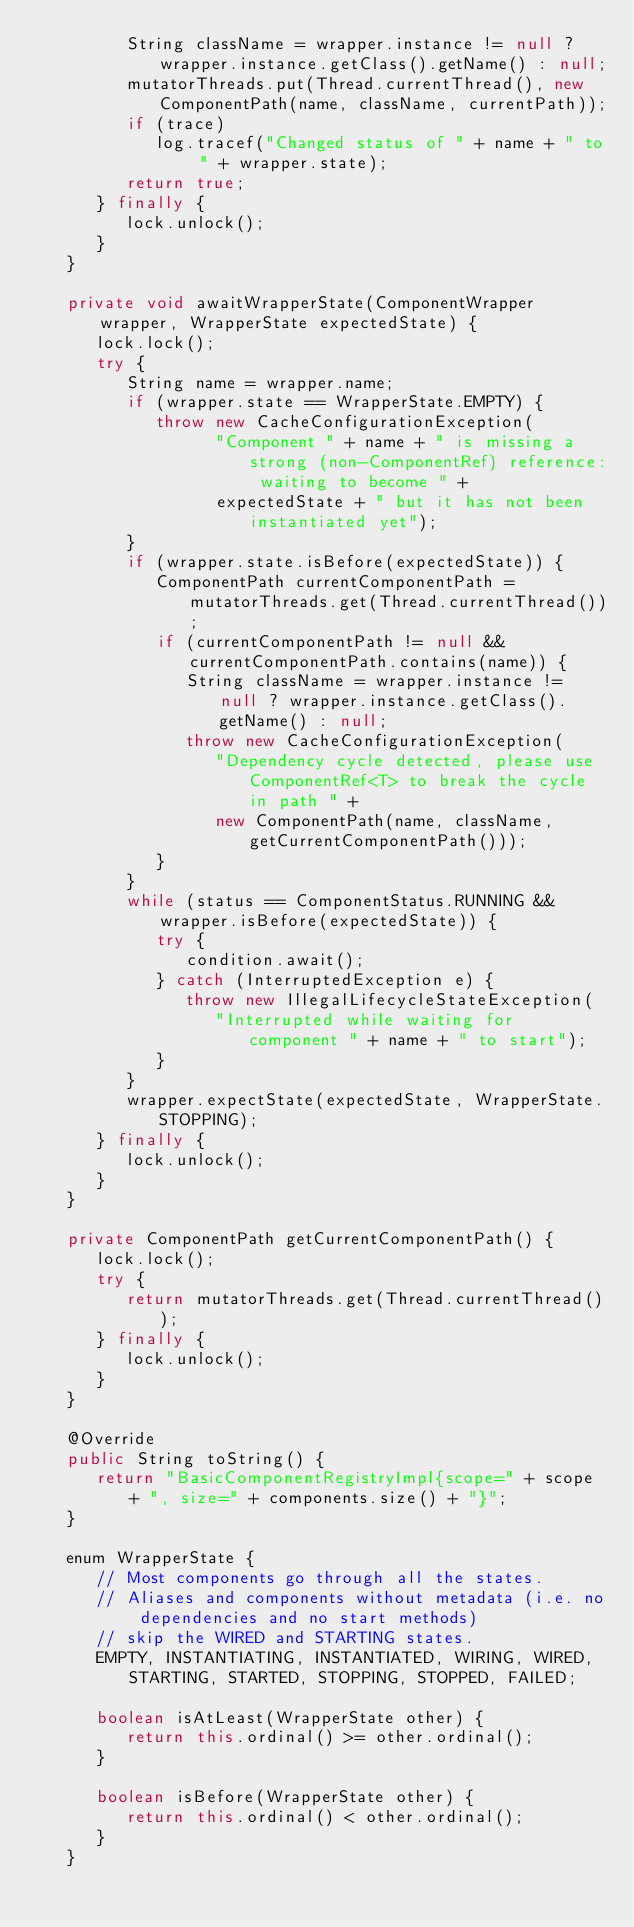<code> <loc_0><loc_0><loc_500><loc_500><_Java_>         String className = wrapper.instance != null ? wrapper.instance.getClass().getName() : null;
         mutatorThreads.put(Thread.currentThread(), new ComponentPath(name, className, currentPath));
         if (trace)
            log.tracef("Changed status of " + name + " to " + wrapper.state);
         return true;
      } finally {
         lock.unlock();
      }
   }

   private void awaitWrapperState(ComponentWrapper wrapper, WrapperState expectedState) {
      lock.lock();
      try {
         String name = wrapper.name;
         if (wrapper.state == WrapperState.EMPTY) {
            throw new CacheConfigurationException(
                  "Component " + name + " is missing a strong (non-ComponentRef) reference: waiting to become " +
                  expectedState + " but it has not been instantiated yet");
         }
         if (wrapper.state.isBefore(expectedState)) {
            ComponentPath currentComponentPath = mutatorThreads.get(Thread.currentThread());
            if (currentComponentPath != null && currentComponentPath.contains(name)) {
               String className = wrapper.instance != null ? wrapper.instance.getClass().getName() : null;
               throw new CacheConfigurationException(
                  "Dependency cycle detected, please use ComponentRef<T> to break the cycle in path " +
                  new ComponentPath(name, className, getCurrentComponentPath()));
            }
         }
         while (status == ComponentStatus.RUNNING && wrapper.isBefore(expectedState)) {
            try {
               condition.await();
            } catch (InterruptedException e) {
               throw new IllegalLifecycleStateException(
                  "Interrupted while waiting for component " + name + " to start");
            }
         }
         wrapper.expectState(expectedState, WrapperState.STOPPING);
      } finally {
         lock.unlock();
      }
   }

   private ComponentPath getCurrentComponentPath() {
      lock.lock();
      try {
         return mutatorThreads.get(Thread.currentThread());
      } finally {
         lock.unlock();
      }
   }

   @Override
   public String toString() {
      return "BasicComponentRegistryImpl{scope=" + scope + ", size=" + components.size() + "}";
   }

   enum WrapperState {
      // Most components go through all the states.
      // Aliases and components without metadata (i.e. no dependencies and no start methods)
      // skip the WIRED and STARTING states.
      EMPTY, INSTANTIATING, INSTANTIATED, WIRING, WIRED, STARTING, STARTED, STOPPING, STOPPED, FAILED;

      boolean isAtLeast(WrapperState other) {
         return this.ordinal() >= other.ordinal();
      }

      boolean isBefore(WrapperState other) {
         return this.ordinal() < other.ordinal();
      }
   }
</code> 